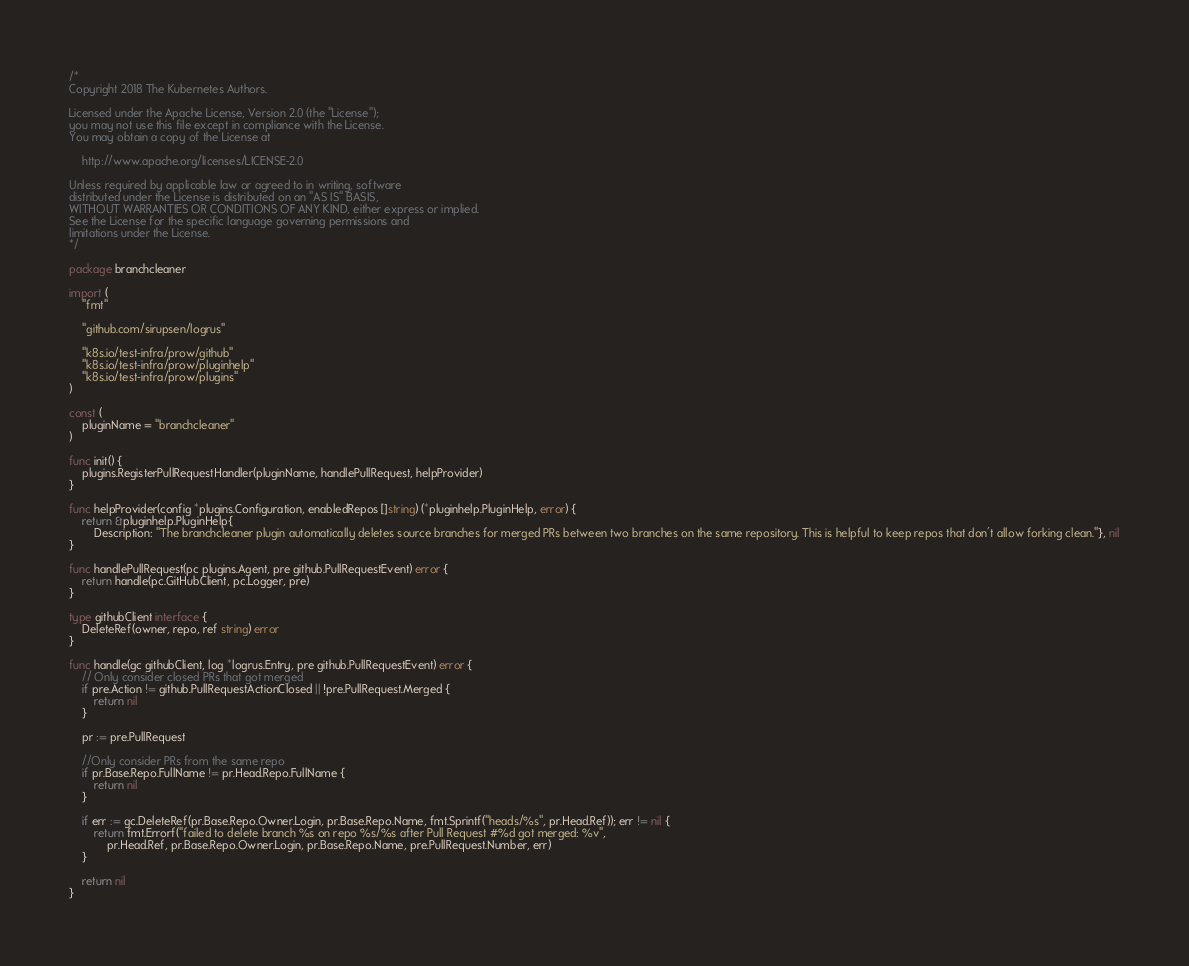Convert code to text. <code><loc_0><loc_0><loc_500><loc_500><_Go_>/*
Copyright 2018 The Kubernetes Authors.

Licensed under the Apache License, Version 2.0 (the "License");
you may not use this file except in compliance with the License.
You may obtain a copy of the License at

    http://www.apache.org/licenses/LICENSE-2.0

Unless required by applicable law or agreed to in writing, software
distributed under the License is distributed on an "AS IS" BASIS,
WITHOUT WARRANTIES OR CONDITIONS OF ANY KIND, either express or implied.
See the License for the specific language governing permissions and
limitations under the License.
*/

package branchcleaner

import (
	"fmt"

	"github.com/sirupsen/logrus"

	"k8s.io/test-infra/prow/github"
	"k8s.io/test-infra/prow/pluginhelp"
	"k8s.io/test-infra/prow/plugins"
)

const (
	pluginName = "branchcleaner"
)

func init() {
	plugins.RegisterPullRequestHandler(pluginName, handlePullRequest, helpProvider)
}

func helpProvider(config *plugins.Configuration, enabledRepos []string) (*pluginhelp.PluginHelp, error) {
	return &pluginhelp.PluginHelp{
		Description: "The branchcleaner plugin automatically deletes source branches for merged PRs between two branches on the same repository. This is helpful to keep repos that don't allow forking clean."}, nil
}

func handlePullRequest(pc plugins.Agent, pre github.PullRequestEvent) error {
	return handle(pc.GitHubClient, pc.Logger, pre)
}

type githubClient interface {
	DeleteRef(owner, repo, ref string) error
}

func handle(gc githubClient, log *logrus.Entry, pre github.PullRequestEvent) error {
	// Only consider closed PRs that got merged
	if pre.Action != github.PullRequestActionClosed || !pre.PullRequest.Merged {
		return nil
	}

	pr := pre.PullRequest

	//Only consider PRs from the same repo
	if pr.Base.Repo.FullName != pr.Head.Repo.FullName {
		return nil
	}

	if err := gc.DeleteRef(pr.Base.Repo.Owner.Login, pr.Base.Repo.Name, fmt.Sprintf("heads/%s", pr.Head.Ref)); err != nil {
		return fmt.Errorf("failed to delete branch %s on repo %s/%s after Pull Request #%d got merged: %v",
			pr.Head.Ref, pr.Base.Repo.Owner.Login, pr.Base.Repo.Name, pre.PullRequest.Number, err)
	}

	return nil
}
</code> 